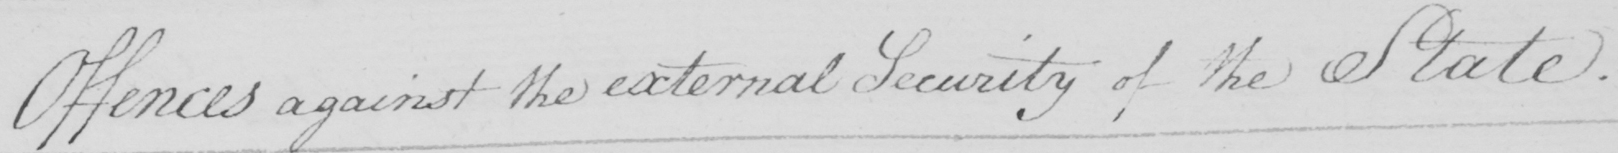Please provide the text content of this handwritten line. Offences against the external Security of the State . 